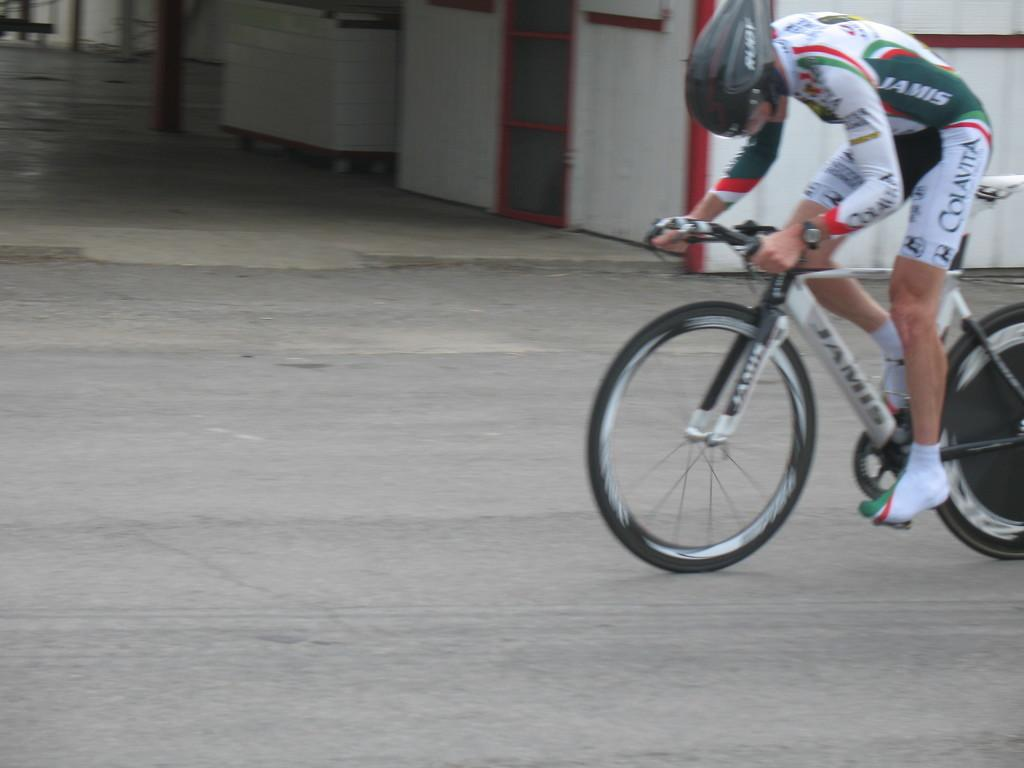What is the person in the image doing? The person is riding a bicycle on the right side of the image. Where is the person riding the bicycle? The person is on the road. What safety precaution is the person taking while riding the bicycle? The person is wearing a helmet. What can be seen at the top of the image? There is a box, a shelter, and poles visible at the top of the image. What type of screw is being used to hold the structure together in the image? There is no structure or screw present in the image; it features a person riding a bicycle on the road. 